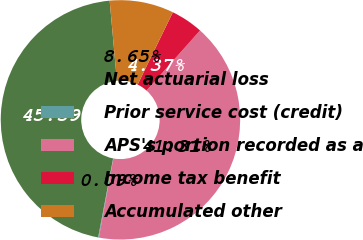Convert chart. <chart><loc_0><loc_0><loc_500><loc_500><pie_chart><fcel>Net actuarial loss<fcel>Prior service cost (credit)<fcel>APS's portion recorded as a<fcel>Income tax benefit<fcel>Accumulated other<nl><fcel>45.59%<fcel>0.09%<fcel>41.31%<fcel>4.37%<fcel>8.65%<nl></chart> 